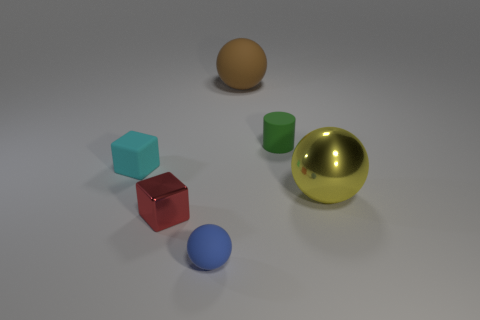Subtract all red cylinders. Subtract all brown balls. How many cylinders are left? 1 Add 3 small things. How many objects exist? 9 Subtract all cylinders. How many objects are left? 5 Subtract 1 cyan cubes. How many objects are left? 5 Subtract all brown objects. Subtract all metallic cubes. How many objects are left? 4 Add 2 tiny red metal cubes. How many tiny red metal cubes are left? 3 Add 5 blue shiny blocks. How many blue shiny blocks exist? 5 